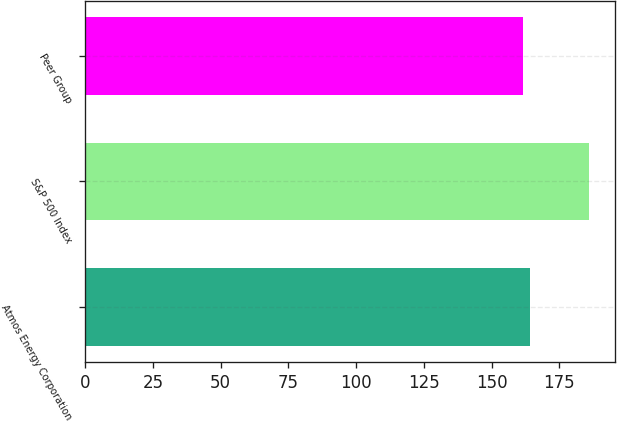Convert chart to OTSL. <chart><loc_0><loc_0><loc_500><loc_500><bar_chart><fcel>Atmos Energy Corporation<fcel>S&P 500 Index<fcel>Peer Group<nl><fcel>164.13<fcel>186.05<fcel>161.7<nl></chart> 